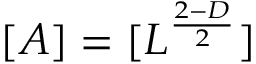Convert formula to latex. <formula><loc_0><loc_0><loc_500><loc_500>[ A ] = [ L ^ { \frac { 2 - D } { 2 } } ]</formula> 